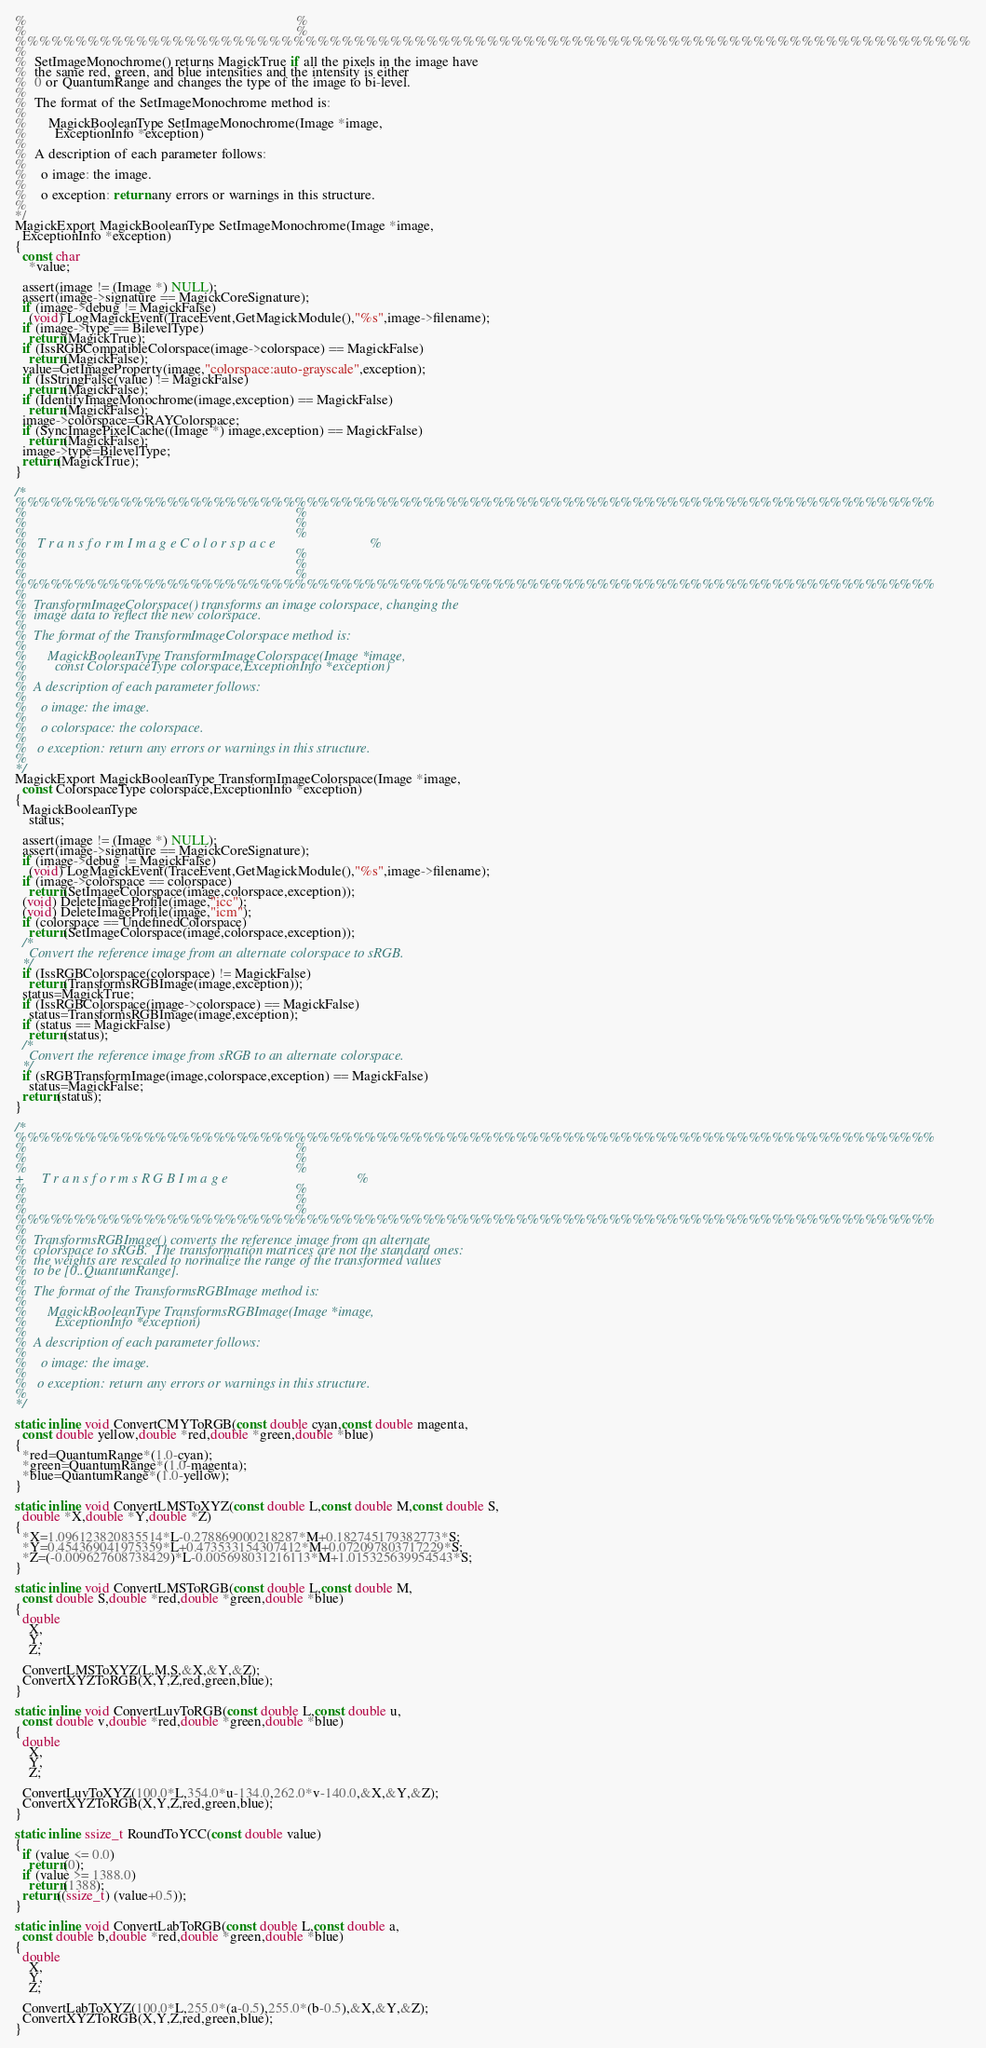Convert code to text. <code><loc_0><loc_0><loc_500><loc_500><_C_>%                                                                             %
%                                                                             %
%%%%%%%%%%%%%%%%%%%%%%%%%%%%%%%%%%%%%%%%%%%%%%%%%%%%%%%%%%%%%%%%%%%%%%%%%%%%%%%
%
%  SetImageMonochrome() returns MagickTrue if all the pixels in the image have
%  the same red, green, and blue intensities and the intensity is either
%  0 or QuantumRange and changes the type of the image to bi-level.
%
%  The format of the SetImageMonochrome method is:
%
%      MagickBooleanType SetImageMonochrome(Image *image,
%        ExceptionInfo *exception)
%
%  A description of each parameter follows:
%
%    o image: the image.
%
%    o exception: return any errors or warnings in this structure.
%
*/
MagickExport MagickBooleanType SetImageMonochrome(Image *image,
  ExceptionInfo *exception)
{
  const char
    *value;

  assert(image != (Image *) NULL);
  assert(image->signature == MagickCoreSignature);
  if (image->debug != MagickFalse)
    (void) LogMagickEvent(TraceEvent,GetMagickModule(),"%s",image->filename);
  if (image->type == BilevelType)
    return(MagickTrue);
  if (IssRGBCompatibleColorspace(image->colorspace) == MagickFalse)
    return(MagickFalse);
  value=GetImageProperty(image,"colorspace:auto-grayscale",exception);
  if (IsStringFalse(value) != MagickFalse)
    return(MagickFalse);
  if (IdentifyImageMonochrome(image,exception) == MagickFalse)
    return(MagickFalse);
  image->colorspace=GRAYColorspace;
  if (SyncImagePixelCache((Image *) image,exception) == MagickFalse)
    return(MagickFalse);
  image->type=BilevelType;
  return(MagickTrue);
}

/*
%%%%%%%%%%%%%%%%%%%%%%%%%%%%%%%%%%%%%%%%%%%%%%%%%%%%%%%%%%%%%%%%%%%%%%%%%%%%%%%
%                                                                             %
%                                                                             %
%                                                                             %
%   T r a n s f o r m I m a g e C o l o r s p a c e                           %
%                                                                             %
%                                                                             %
%                                                                             %
%%%%%%%%%%%%%%%%%%%%%%%%%%%%%%%%%%%%%%%%%%%%%%%%%%%%%%%%%%%%%%%%%%%%%%%%%%%%%%%
%
%  TransformImageColorspace() transforms an image colorspace, changing the
%  image data to reflect the new colorspace.
%
%  The format of the TransformImageColorspace method is:
%
%      MagickBooleanType TransformImageColorspace(Image *image,
%        const ColorspaceType colorspace,ExceptionInfo *exception)
%
%  A description of each parameter follows:
%
%    o image: the image.
%
%    o colorspace: the colorspace.
%
%   o exception: return any errors or warnings in this structure.
%
*/
MagickExport MagickBooleanType TransformImageColorspace(Image *image,
  const ColorspaceType colorspace,ExceptionInfo *exception)
{
  MagickBooleanType
    status;

  assert(image != (Image *) NULL);
  assert(image->signature == MagickCoreSignature);
  if (image->debug != MagickFalse)
    (void) LogMagickEvent(TraceEvent,GetMagickModule(),"%s",image->filename);
  if (image->colorspace == colorspace)
    return(SetImageColorspace(image,colorspace,exception));
  (void) DeleteImageProfile(image,"icc");
  (void) DeleteImageProfile(image,"icm");
  if (colorspace == UndefinedColorspace)
    return(SetImageColorspace(image,colorspace,exception));
  /*
    Convert the reference image from an alternate colorspace to sRGB.
  */
  if (IssRGBColorspace(colorspace) != MagickFalse)
    return(TransformsRGBImage(image,exception));
  status=MagickTrue;
  if (IssRGBColorspace(image->colorspace) == MagickFalse)
    status=TransformsRGBImage(image,exception);
  if (status == MagickFalse)
    return(status);
  /*
    Convert the reference image from sRGB to an alternate colorspace.
  */
  if (sRGBTransformImage(image,colorspace,exception) == MagickFalse)
    status=MagickFalse;
  return(status);
}

/*
%%%%%%%%%%%%%%%%%%%%%%%%%%%%%%%%%%%%%%%%%%%%%%%%%%%%%%%%%%%%%%%%%%%%%%%%%%%%%%%
%                                                                             %
%                                                                             %
%                                                                             %
+     T r a n s f o r m s R G B I m a g e                                     %
%                                                                             %
%                                                                             %
%                                                                             %
%%%%%%%%%%%%%%%%%%%%%%%%%%%%%%%%%%%%%%%%%%%%%%%%%%%%%%%%%%%%%%%%%%%%%%%%%%%%%%%
%
%  TransformsRGBImage() converts the reference image from an alternate
%  colorspace to sRGB.  The transformation matrices are not the standard ones:
%  the weights are rescaled to normalize the range of the transformed values
%  to be [0..QuantumRange].
%
%  The format of the TransformsRGBImage method is:
%
%      MagickBooleanType TransformsRGBImage(Image *image,
%        ExceptionInfo *exception)
%
%  A description of each parameter follows:
%
%    o image: the image.
%
%   o exception: return any errors or warnings in this structure.
%
*/

static inline void ConvertCMYToRGB(const double cyan,const double magenta,
  const double yellow,double *red,double *green,double *blue)
{
  *red=QuantumRange*(1.0-cyan);
  *green=QuantumRange*(1.0-magenta);
  *blue=QuantumRange*(1.0-yellow);
}

static inline void ConvertLMSToXYZ(const double L,const double M,const double S,
  double *X,double *Y,double *Z)
{
  *X=1.096123820835514*L-0.278869000218287*M+0.182745179382773*S;
  *Y=0.454369041975359*L+0.473533154307412*M+0.072097803717229*S;
  *Z=(-0.009627608738429)*L-0.005698031216113*M+1.015325639954543*S;
}

static inline void ConvertLMSToRGB(const double L,const double M,
  const double S,double *red,double *green,double *blue)
{
  double
    X,
    Y,
    Z;

  ConvertLMSToXYZ(L,M,S,&X,&Y,&Z);
  ConvertXYZToRGB(X,Y,Z,red,green,blue);
}

static inline void ConvertLuvToRGB(const double L,const double u,
  const double v,double *red,double *green,double *blue)
{
  double
    X,
    Y,
    Z;

  ConvertLuvToXYZ(100.0*L,354.0*u-134.0,262.0*v-140.0,&X,&Y,&Z);
  ConvertXYZToRGB(X,Y,Z,red,green,blue);
}

static inline ssize_t RoundToYCC(const double value)
{
  if (value <= 0.0)
    return(0);
  if (value >= 1388.0)
    return(1388);
  return((ssize_t) (value+0.5));
}

static inline void ConvertLabToRGB(const double L,const double a,
  const double b,double *red,double *green,double *blue)
{
  double
    X,
    Y,
    Z;

  ConvertLabToXYZ(100.0*L,255.0*(a-0.5),255.0*(b-0.5),&X,&Y,&Z);
  ConvertXYZToRGB(X,Y,Z,red,green,blue);
}
</code> 